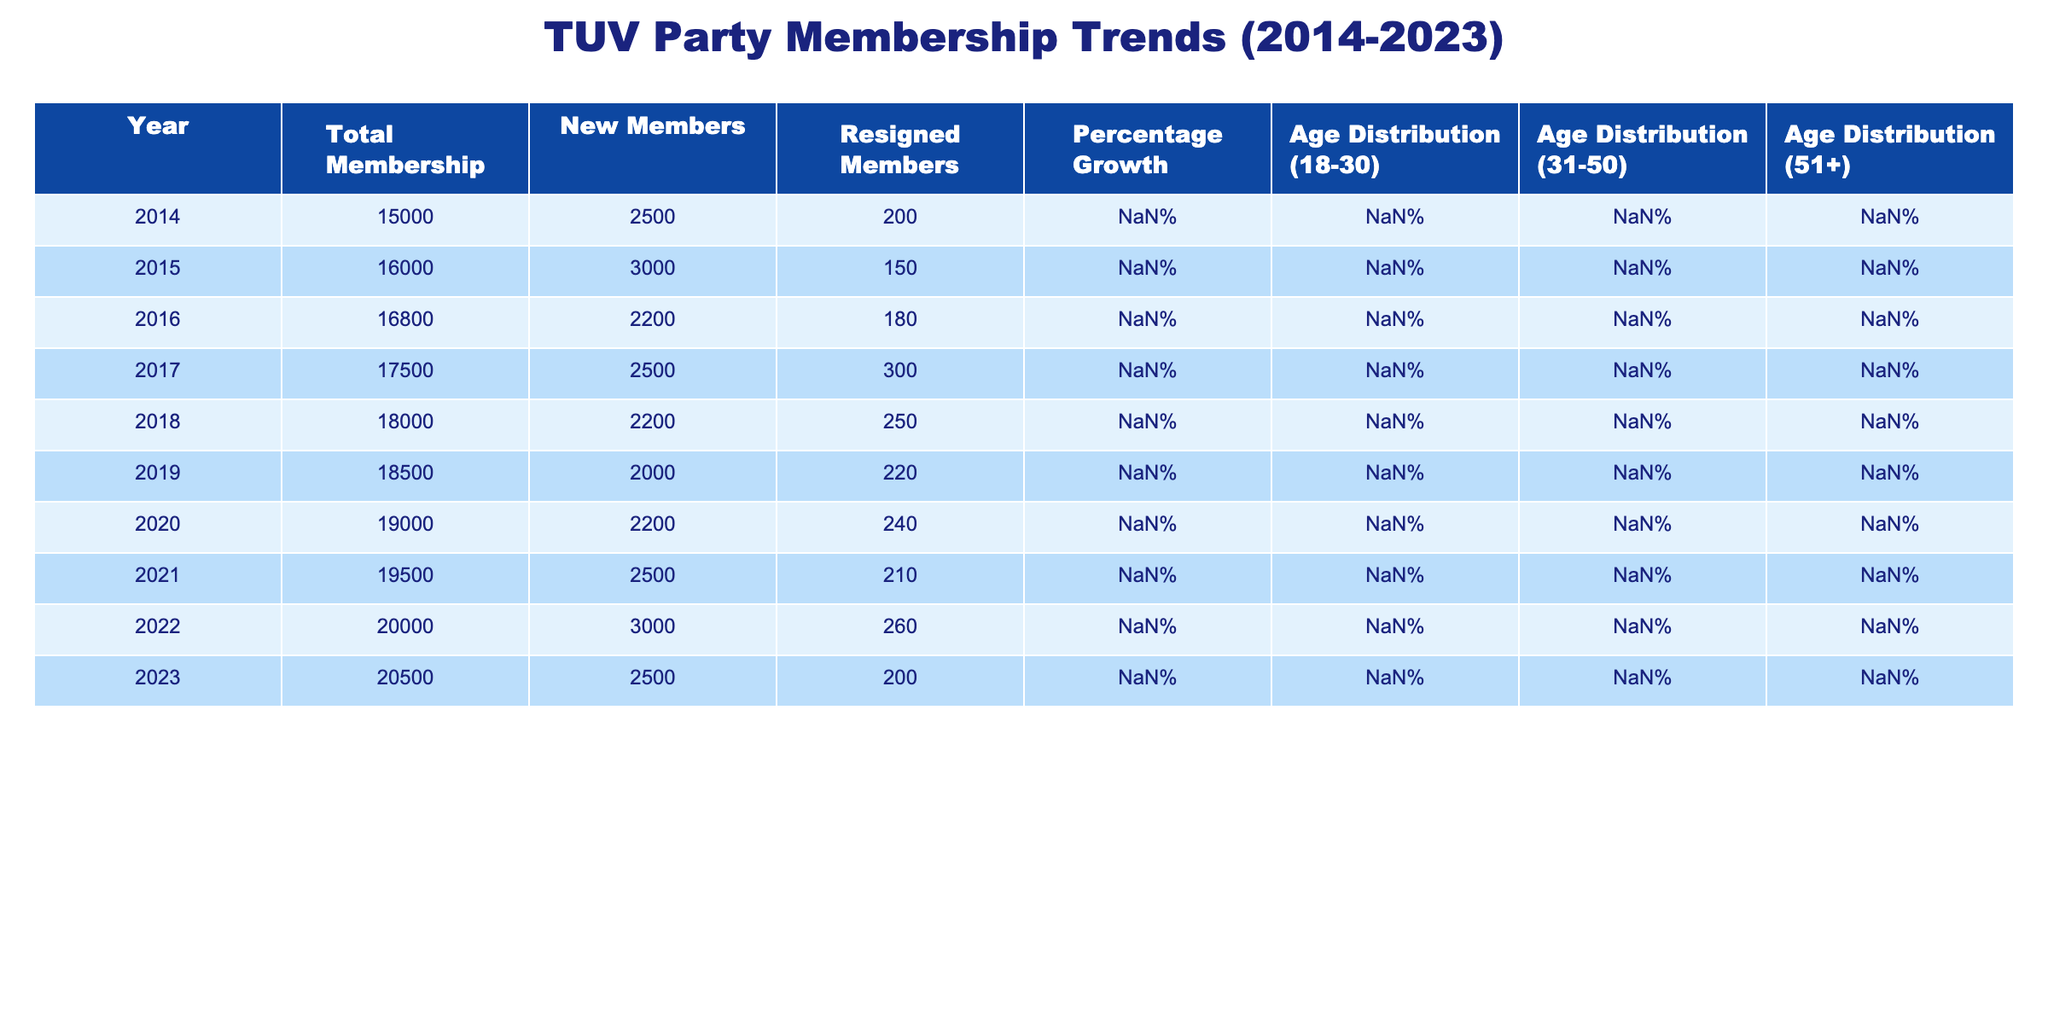What was the total membership of the TUV Party in 2020? In the table under the "Total Membership" column for the year 2020, the value is 19000.
Answer: 19000 What is the percentage growth of membership from 2019 to 2020? The percentage growth for 2019 is 2.78% and for 2020 is 2.70%. The growth from 2019 to 2020 is calculated by finding the difference in membership (19000 - 18500 = 500) and dividing it by the previous year's membership (18500), then multiplying by 100. The percentage change is (500/18500) * 100 = ~2.70%, which matches the figure shown for 2020.
Answer: 2.70% How many new members joined the TUV Party in 2022? Referring to the table, the "New Members" column for 2022 shows a value of 3000.
Answer: 3000 Did the number of resigned members increase from 2014 to 2015? In 2014, the number of resigned members is 200, and in 2015 it is 150. Since 150 is less than 200, the number of resignations actually decreased from 2014 to 2015.
Answer: No What was the average percentage growth over the last decade (2014-2023)? To calculate the average percentage growth, we sum the values of "Percentage Growth" from 2014 to 2023: 20% + 6.67% + 5% + 4.17% + 2.86% + 2.78% + 2.70% + 2.63% + 2.56% + 2.50% = 49.57%. Then we divide this total by the number of years (10): 49.57% / 10 = 4.957% average growth.
Answer: 4.96% Which year had the highest number of new members? Looking at the "New Members" column, the year 2015 had the highest number of new members at 3000.
Answer: 2015 What percentage of TUV Party members were aged 31-50 in 2023? In the table for the year 2023, the "Age Distribution (31-50)" shows 41%.
Answer: 41% How many total members resigned from TUV Party over the last decade (2014-2023)? We sum the "Resigned Members" column from each year: 200 + 150 + 180 + 300 + 250 + 220 + 240 + 210 + 260 + 200 = 2010 total members resigned over the decade.
Answer: 2010 Was there a consistent increase in total membership every year from 2014 to 2023? Examining the "Total Membership" from each year indicates steady growth; every year's total membership increased compared to the previous year except for 2020-2021 which had a small fluctuation. Hence, it was not completely consistent but showed an overall increasing trend.
Answer: No 